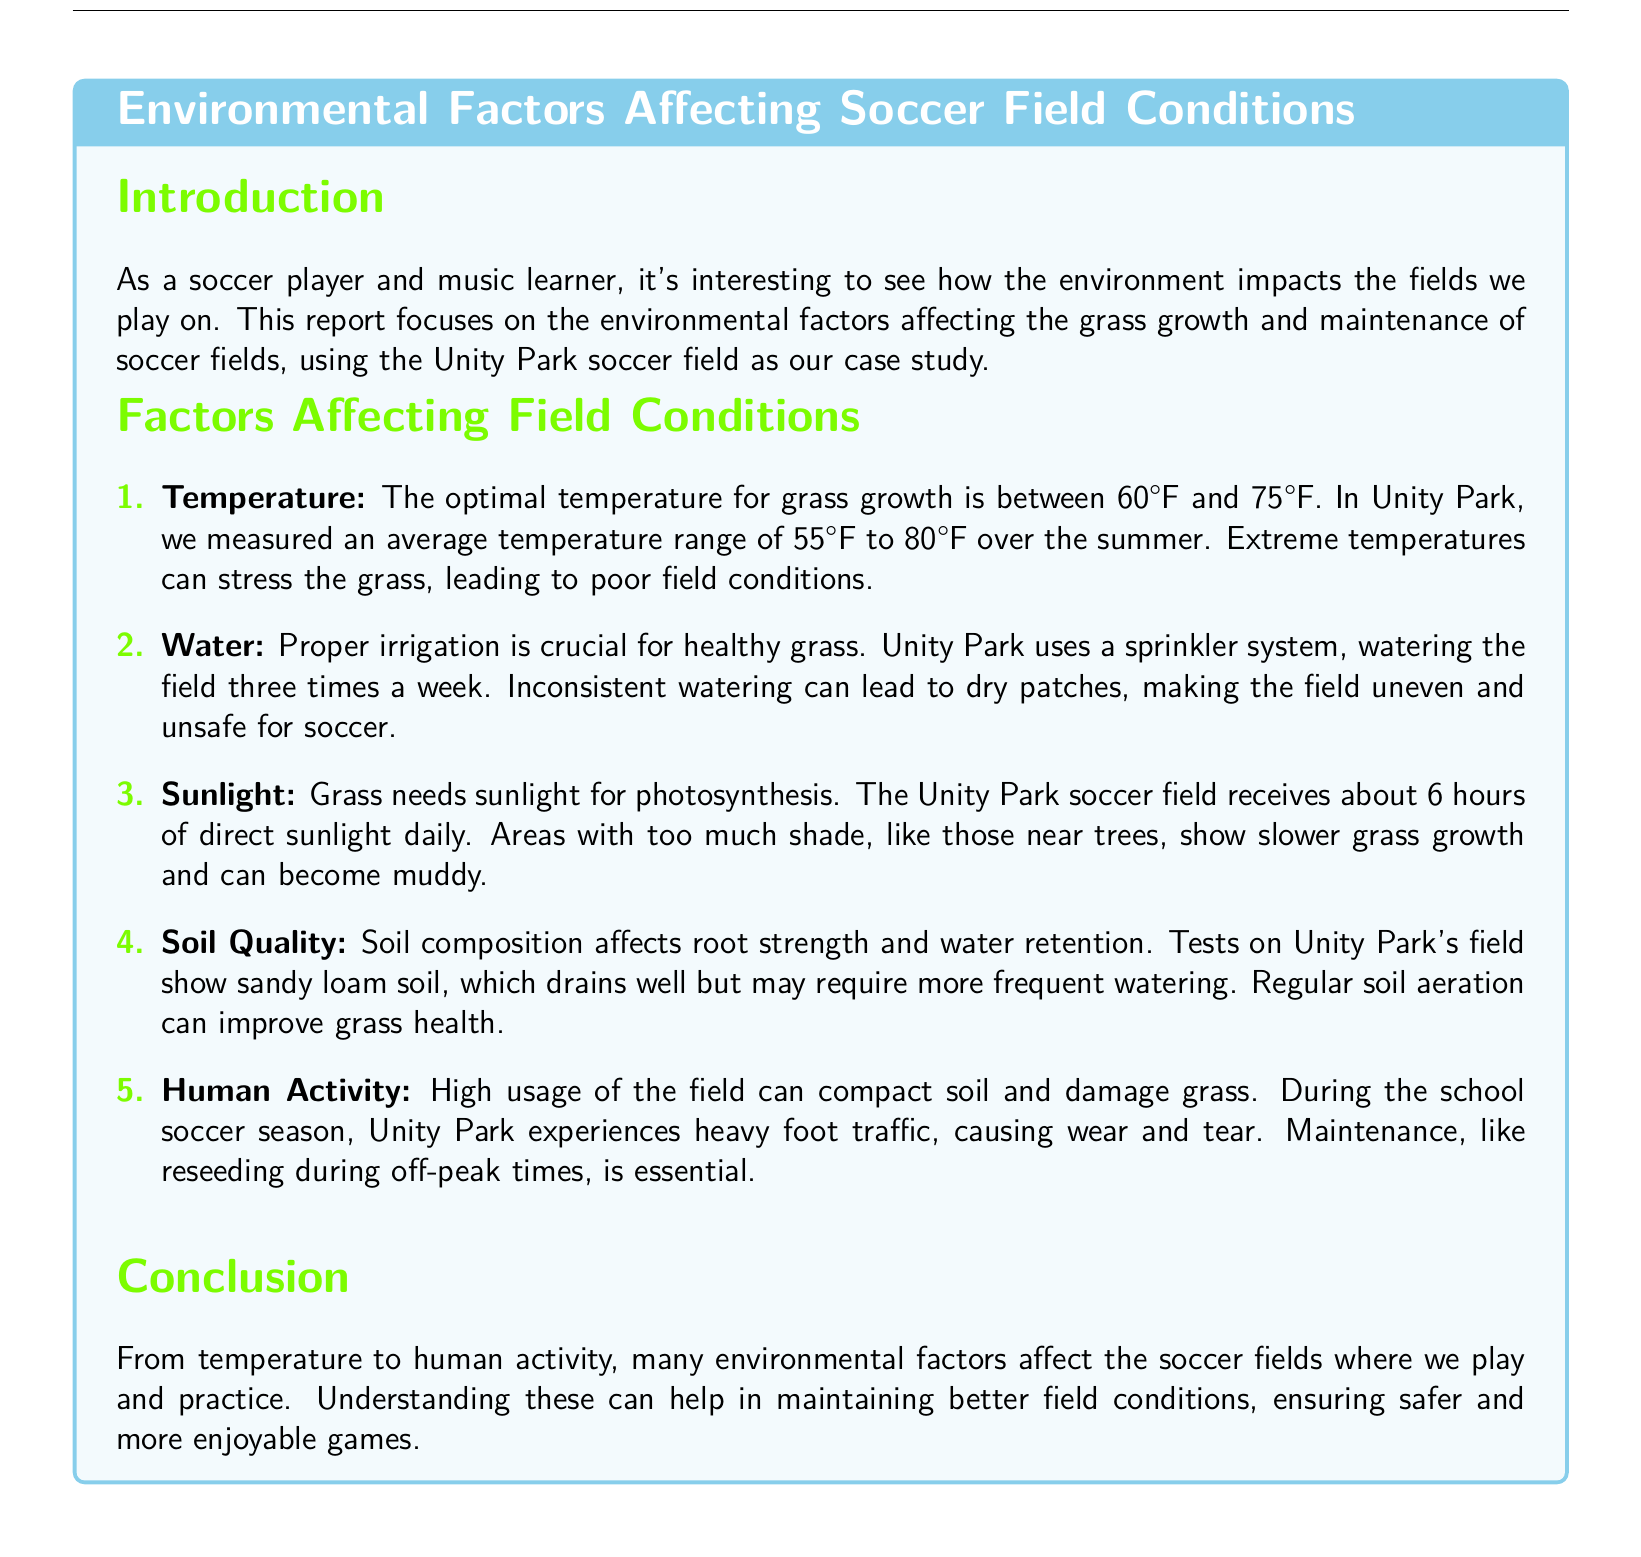what is the optimal temperature range for grass growth? The document states that the optimal temperature for grass growth is between 60°F and 75°F.
Answer: 60°F to 75°F how often does Unity Park water the field? It mentions that Unity Park waters the field three times a week.
Answer: three times a week what type of soil is present in Unity Park? The document indicates that tests show sandy loam soil at Unity Park.
Answer: sandy loam how many hours of direct sunlight does the soccer field receive daily? The report mentions that the field receives about 6 hours of direct sunlight daily.
Answer: 6 hours why is maintenance like reseeding important? The document explains that high usage of the field can compact soil and damage grass, making maintenance essential.
Answer: to prevent soil compaction and grass damage what affects grass growth in shaded areas? It states that areas with too much shade show slower grass growth.
Answer: slower grass growth what is the impact of extreme temperatures on grass? The document notes that extreme temperatures can stress the grass, leading to poor field conditions.
Answer: stress to grass which season experiences heavy foot traffic at Unity Park? The document mentions that heavy foot traffic occurs during the school soccer season.
Answer: school soccer season 